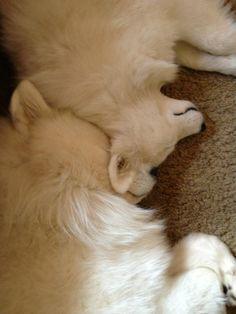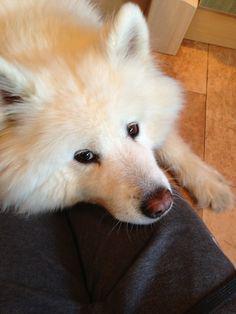The first image is the image on the left, the second image is the image on the right. Assess this claim about the two images: "There are less than four dogs and none of them have their mouth open.". Correct or not? Answer yes or no. Yes. 